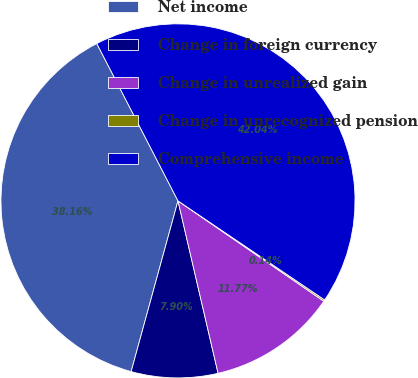Convert chart. <chart><loc_0><loc_0><loc_500><loc_500><pie_chart><fcel>Net income<fcel>Change in foreign currency<fcel>Change in unrealized gain<fcel>Change in unrecognized pension<fcel>Comprehensive income<nl><fcel>38.16%<fcel>7.9%<fcel>11.77%<fcel>0.14%<fcel>42.04%<nl></chart> 